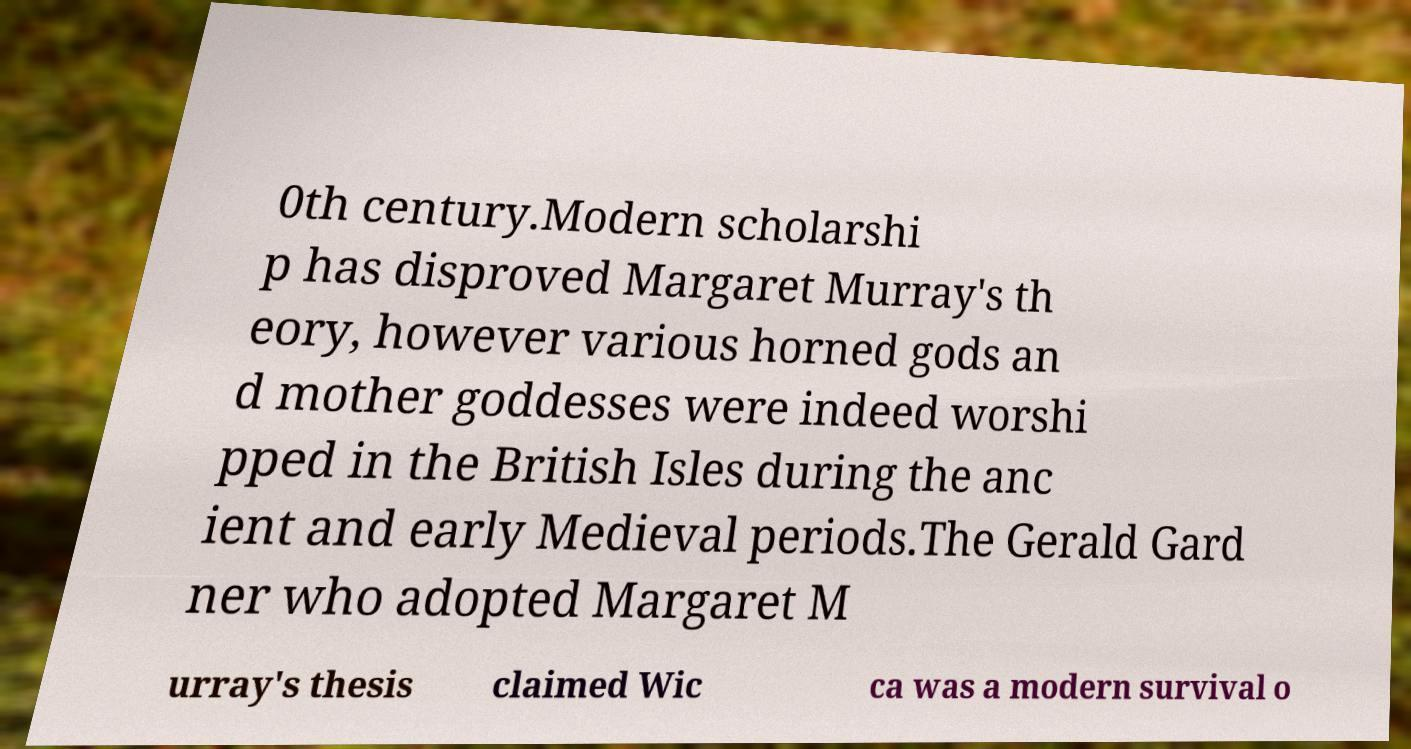Could you extract and type out the text from this image? 0th century.Modern scholarshi p has disproved Margaret Murray's th eory, however various horned gods an d mother goddesses were indeed worshi pped in the British Isles during the anc ient and early Medieval periods.The Gerald Gard ner who adopted Margaret M urray's thesis claimed Wic ca was a modern survival o 